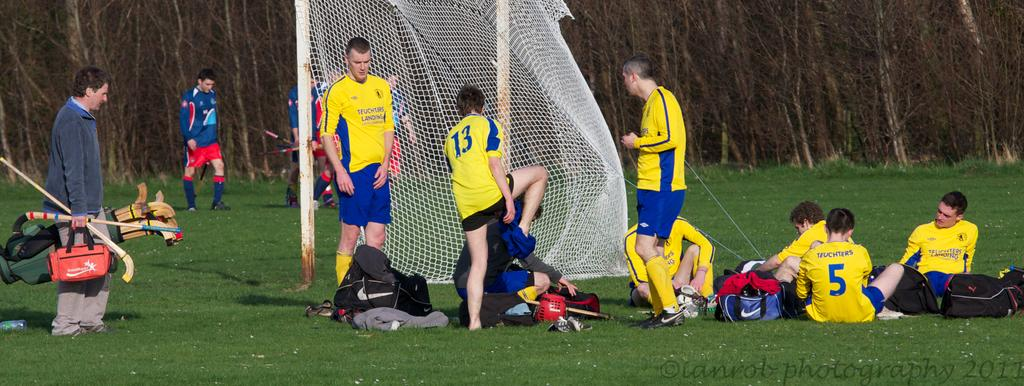<image>
Present a compact description of the photo's key features. a player is sitting down with the number 5 on their back 